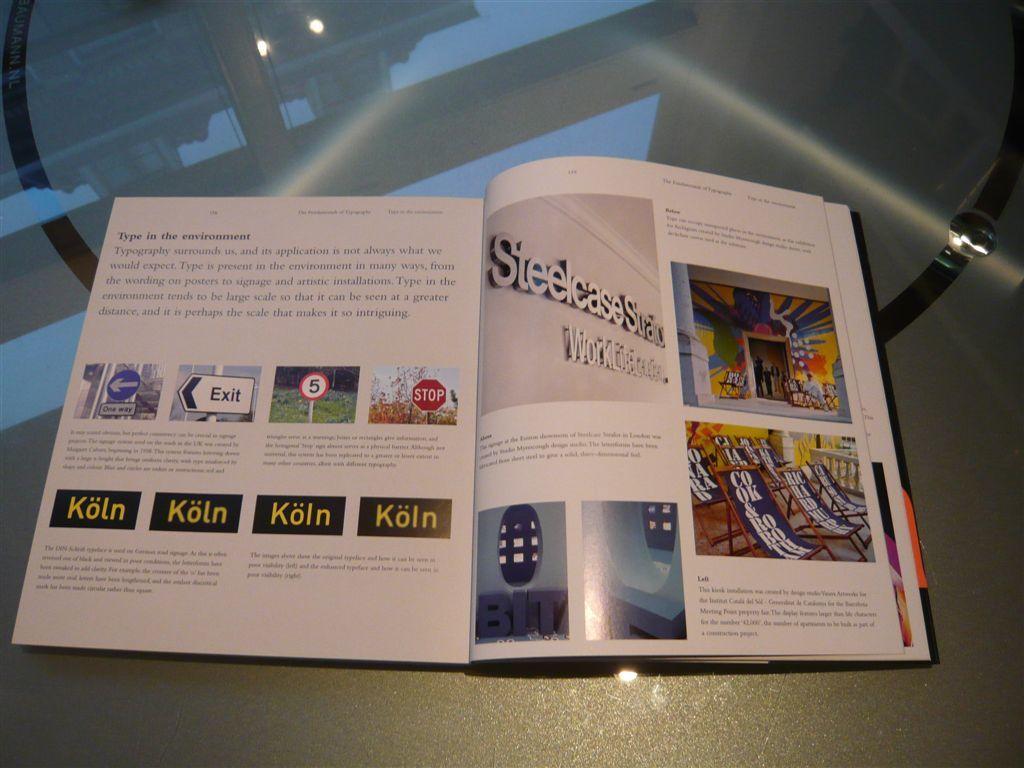What kind of metal is the case?
Your response must be concise. Steel. Which city is named in the publication?
Your answer should be very brief. Koln. 